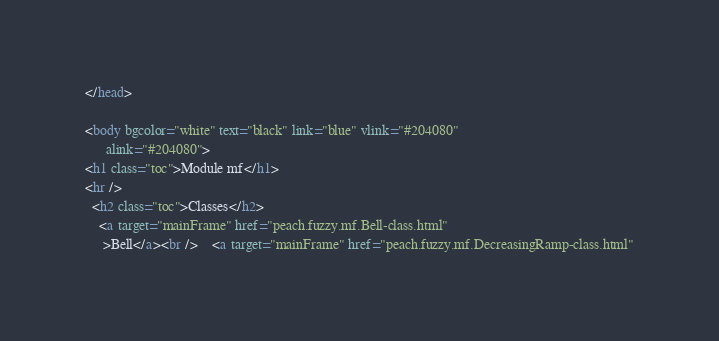<code> <loc_0><loc_0><loc_500><loc_500><_HTML_></head>

<body bgcolor="white" text="black" link="blue" vlink="#204080"
      alink="#204080">
<h1 class="toc">Module mf</h1>
<hr />
  <h2 class="toc">Classes</h2>
    <a target="mainFrame" href="peach.fuzzy.mf.Bell-class.html"
     >Bell</a><br />    <a target="mainFrame" href="peach.fuzzy.mf.DecreasingRamp-class.html"</code> 